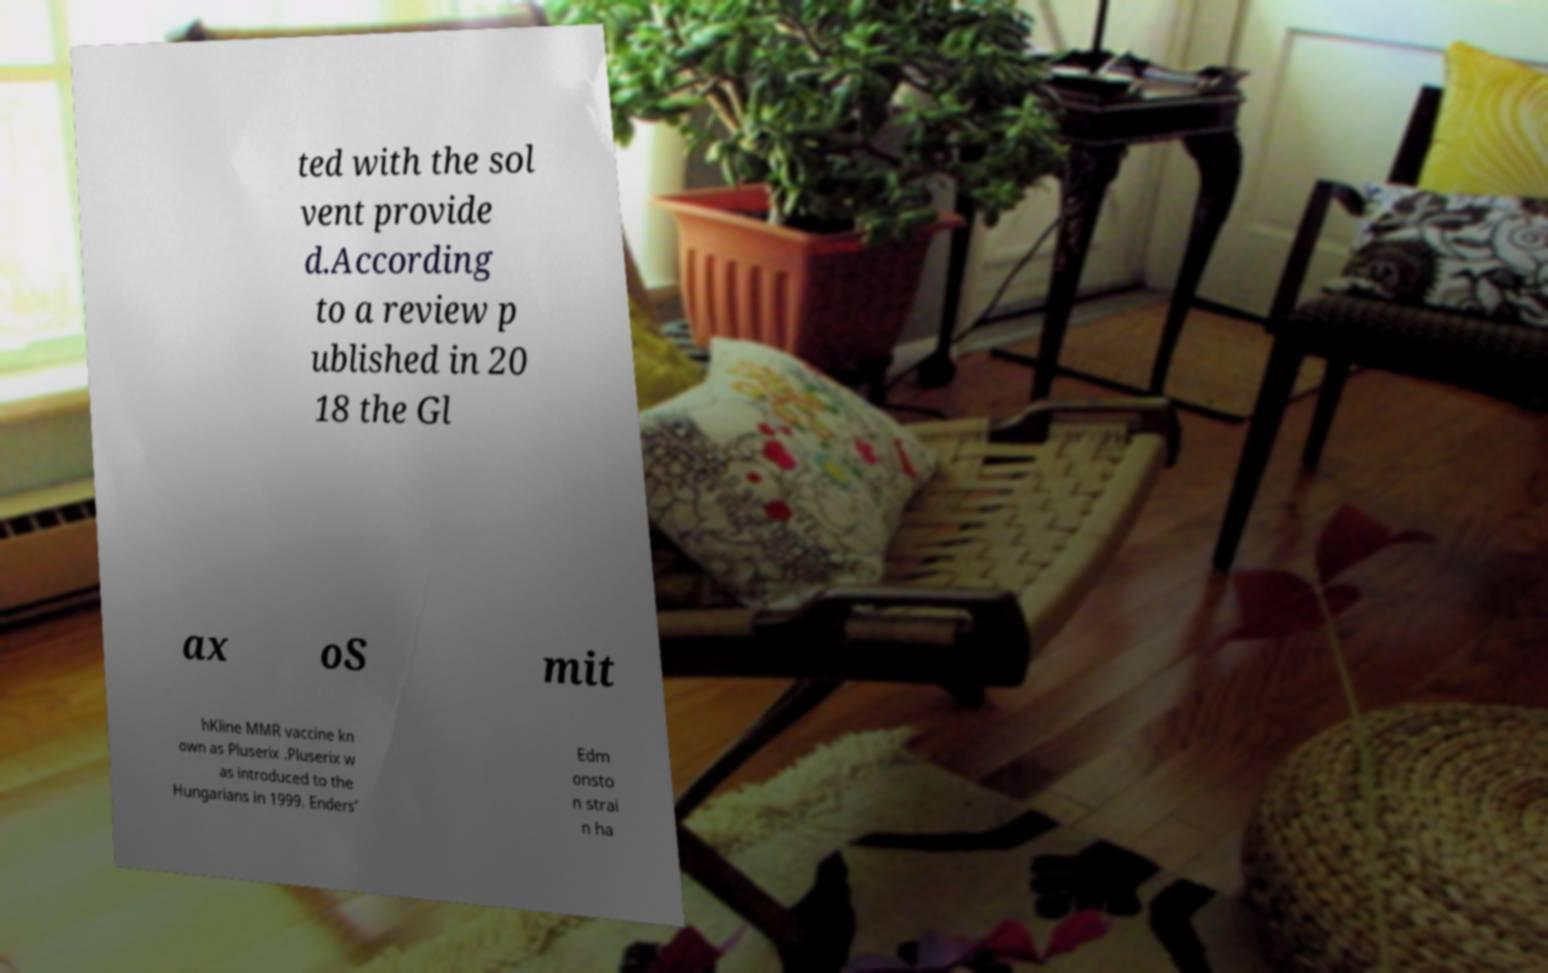There's text embedded in this image that I need extracted. Can you transcribe it verbatim? ted with the sol vent provide d.According to a review p ublished in 20 18 the Gl ax oS mit hKline MMR vaccine kn own as Pluserix .Pluserix w as introduced to the Hungarians in 1999. Enders’ Edm onsto n strai n ha 